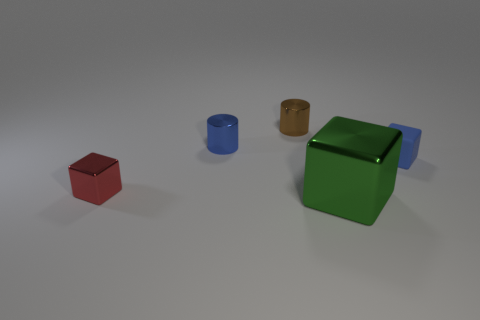Is there any other thing that has the same material as the small blue block?
Your answer should be very brief. No. Do the big thing and the blue block have the same material?
Your answer should be very brief. No. There is a tiny shiny object that is behind the tiny blue cylinder; what number of blue matte objects are on the left side of it?
Your response must be concise. 0. Is there another metallic thing that has the same shape as the large green shiny object?
Offer a terse response. Yes. Do the tiny blue object that is right of the brown shiny thing and the small shiny thing in front of the small rubber block have the same shape?
Provide a short and direct response. Yes. What is the shape of the tiny metal thing that is to the right of the red block and in front of the brown cylinder?
Make the answer very short. Cylinder. Is there a green thing of the same size as the green metal block?
Offer a terse response. No. There is a matte thing; is its color the same as the cylinder left of the tiny brown metal object?
Provide a short and direct response. Yes. What is the material of the red cube?
Provide a short and direct response. Metal. What is the color of the metallic object to the left of the blue metal cylinder?
Provide a succinct answer. Red. 